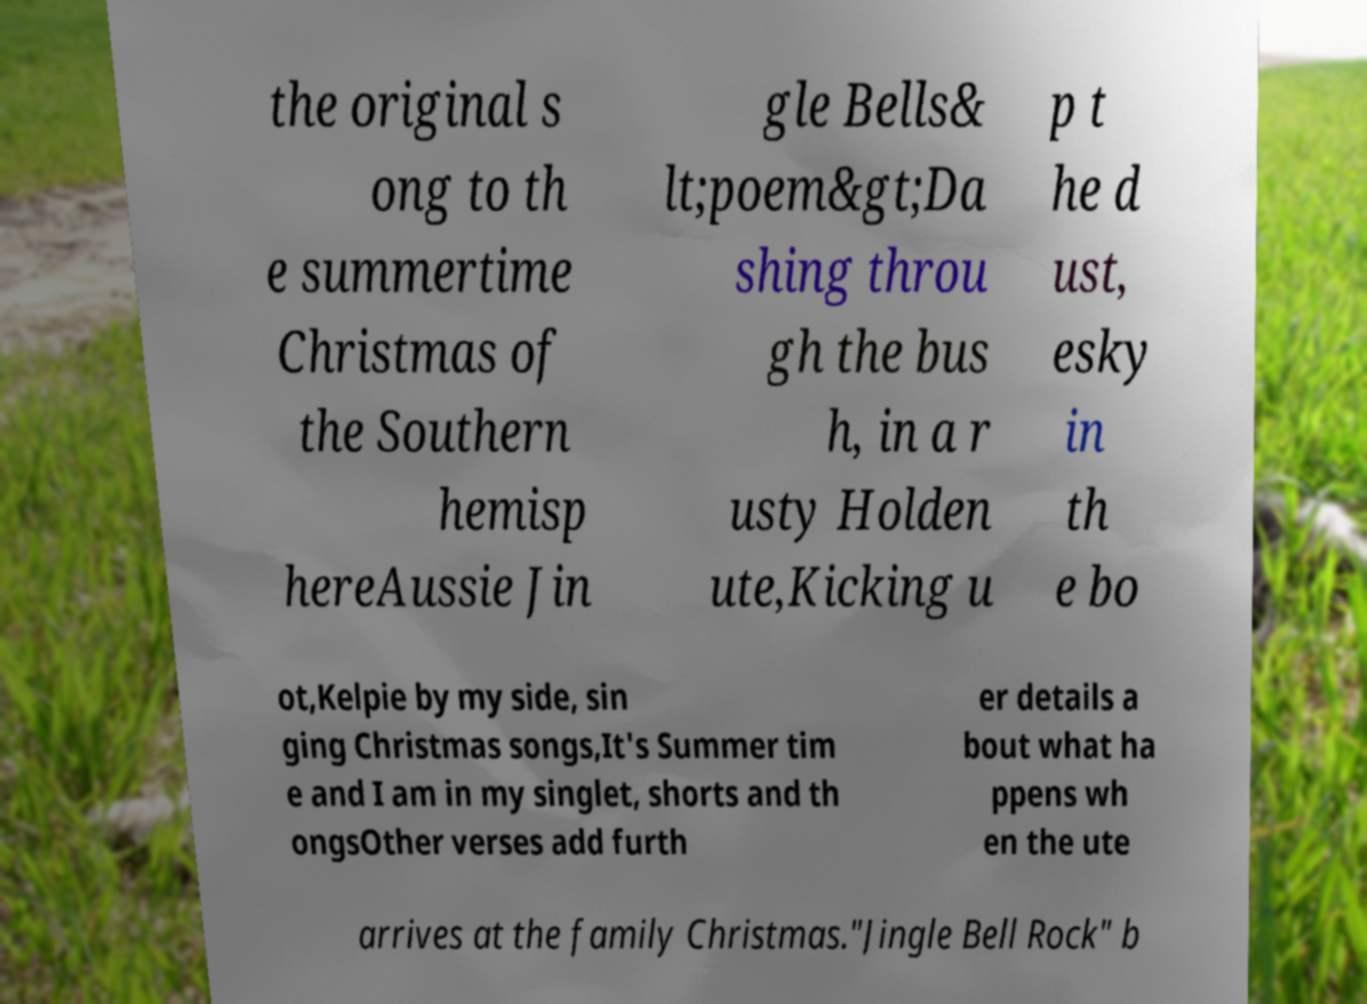For documentation purposes, I need the text within this image transcribed. Could you provide that? the original s ong to th e summertime Christmas of the Southern hemisp hereAussie Jin gle Bells& lt;poem&gt;Da shing throu gh the bus h, in a r usty Holden ute,Kicking u p t he d ust, esky in th e bo ot,Kelpie by my side, sin ging Christmas songs,It's Summer tim e and I am in my singlet, shorts and th ongsOther verses add furth er details a bout what ha ppens wh en the ute arrives at the family Christmas."Jingle Bell Rock" b 